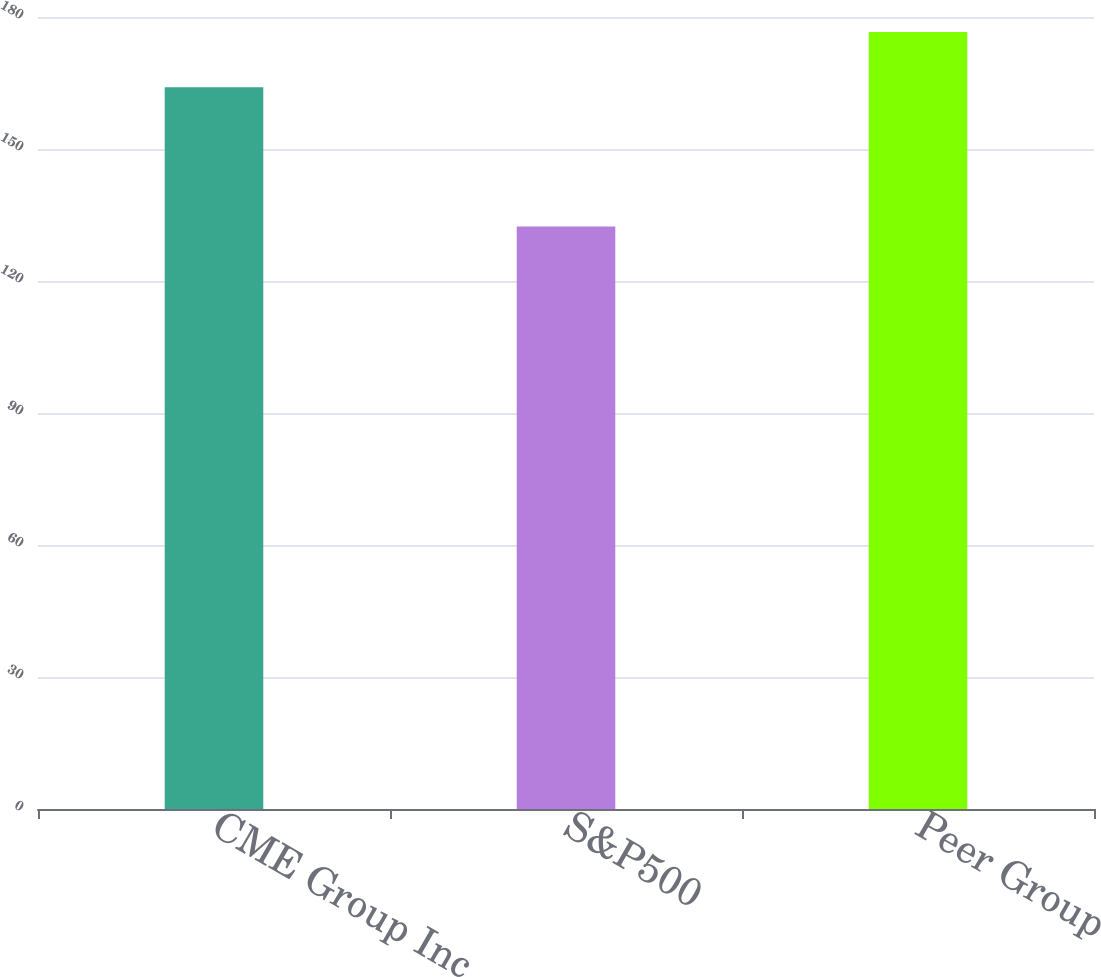Convert chart. <chart><loc_0><loc_0><loc_500><loc_500><bar_chart><fcel>CME Group Inc<fcel>S&P500<fcel>Peer Group<nl><fcel>164.01<fcel>132.39<fcel>176.61<nl></chart> 